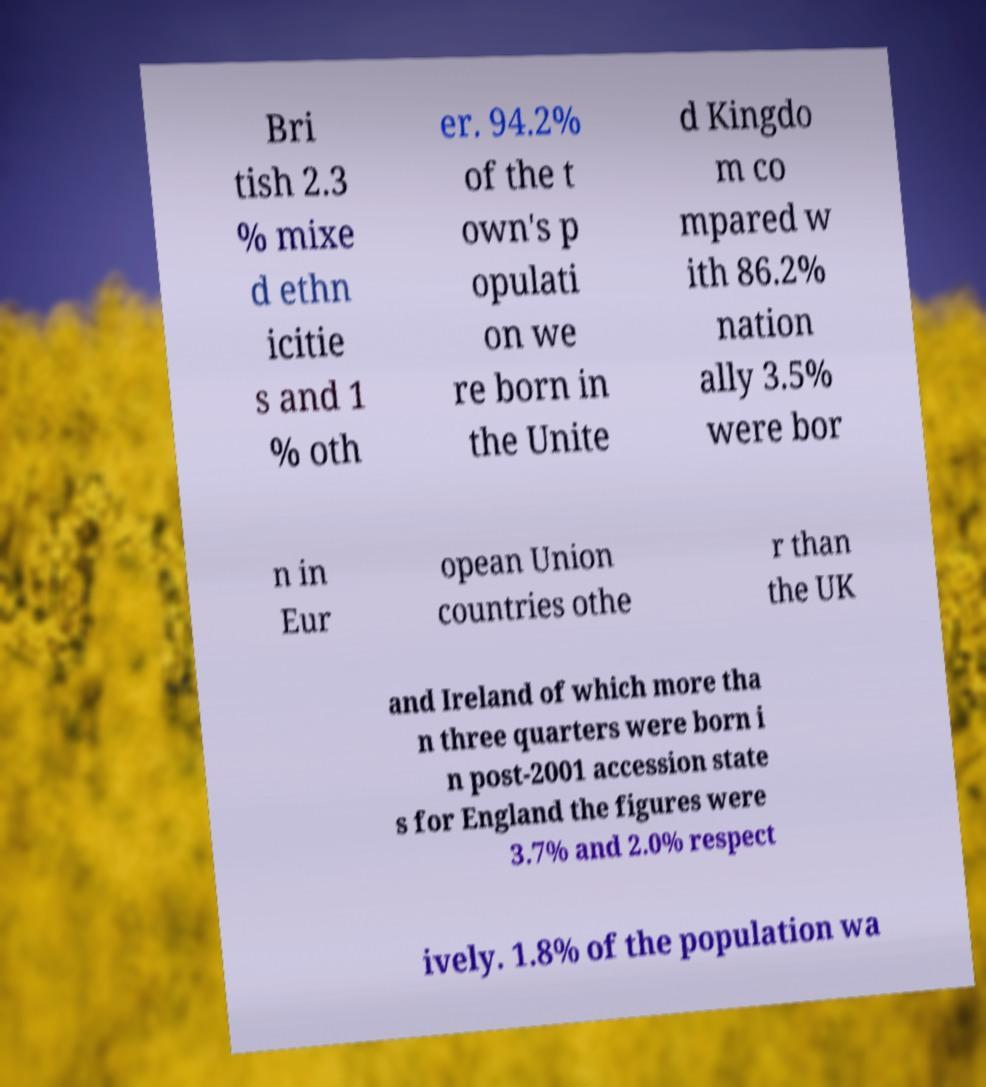Could you assist in decoding the text presented in this image and type it out clearly? Bri tish 2.3 % mixe d ethn icitie s and 1 % oth er. 94.2% of the t own's p opulati on we re born in the Unite d Kingdo m co mpared w ith 86.2% nation ally 3.5% were bor n in Eur opean Union countries othe r than the UK and Ireland of which more tha n three quarters were born i n post-2001 accession state s for England the figures were 3.7% and 2.0% respect ively. 1.8% of the population wa 